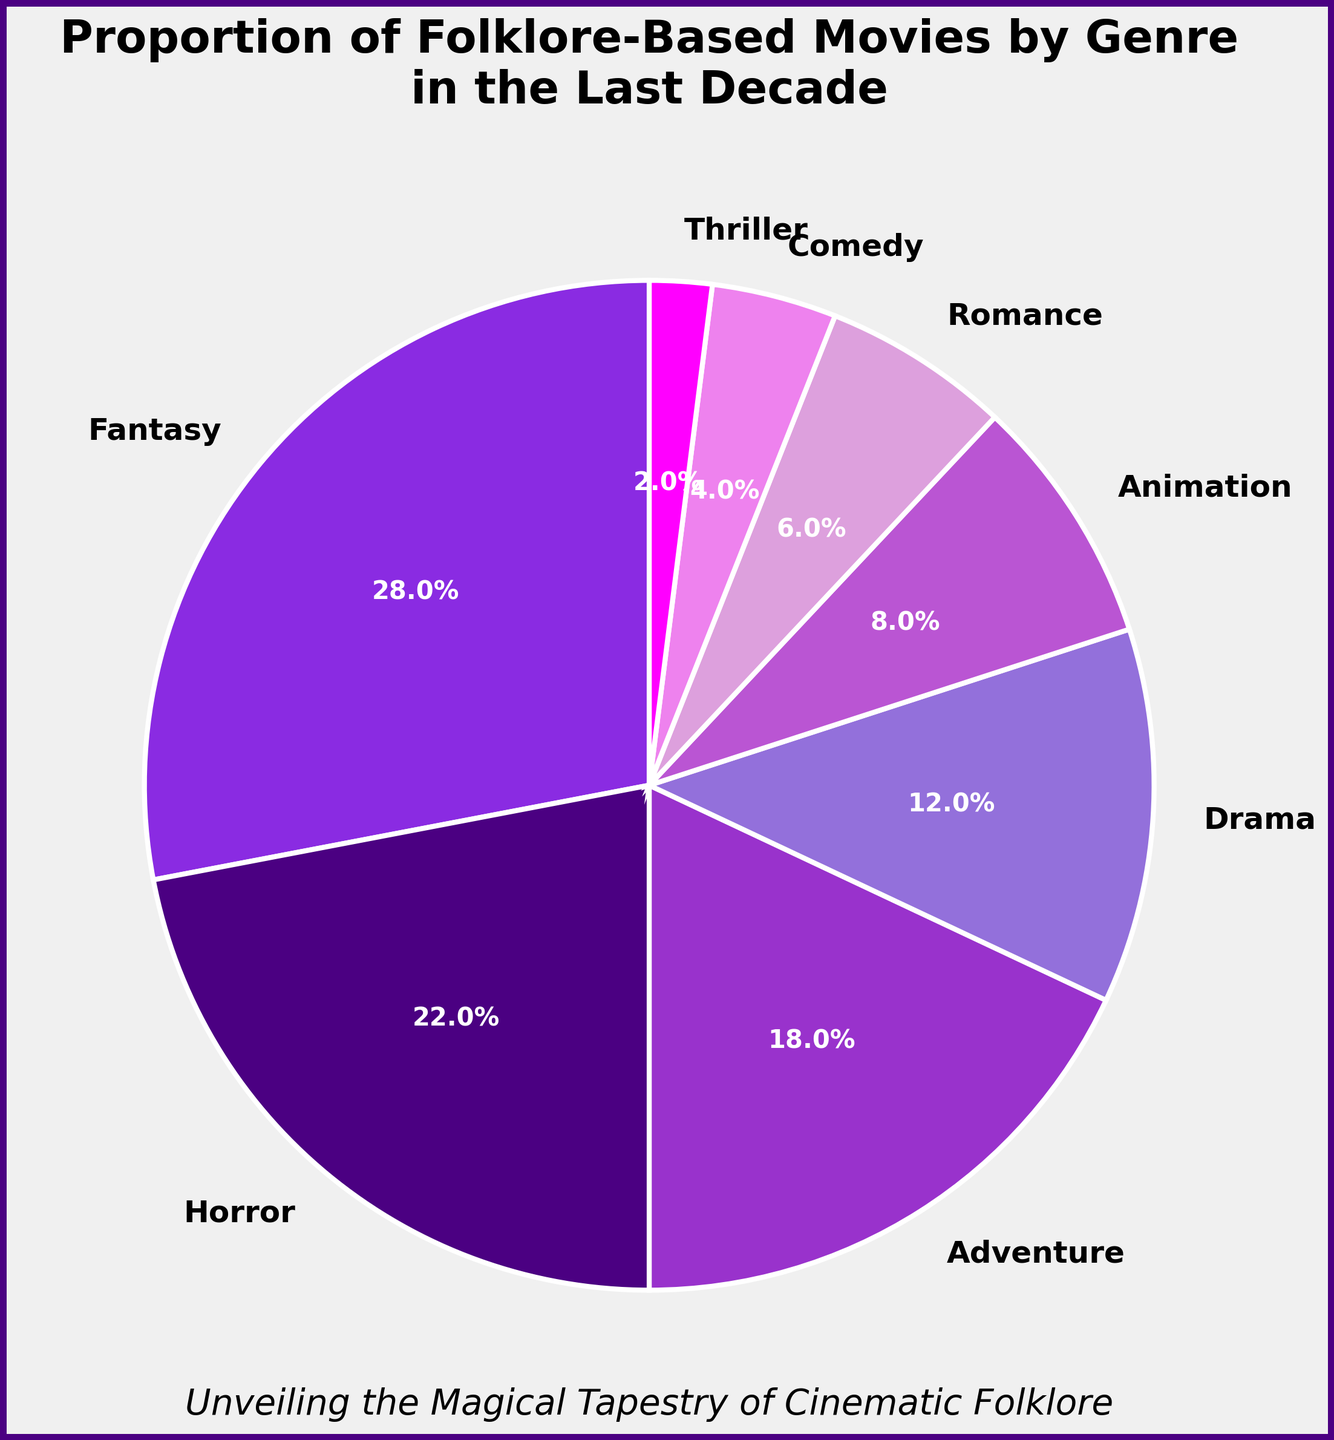What genre has the highest proportion of folklore-based movies? By observing the pie chart, the genre with the largest wedge is the one with the highest proportion. The genre labeled "Fantasy" has the largest wedge.
Answer: Fantasy Between Horror and Comedy, which genre has a higher percentage of folklore-based movies? Comparing the sizes of the wedges labeled "Horror" and "Comedy", "Horror" is significantly larger than "Comedy".
Answer: Horror What is the combined percentage of folklore-based movies in the Drama and Animation genres? The wedges for Drama and Animation can be individually identified and their percentages summed. Drama is 12% and Animation is 8%. The combined percentage is 12% + 8% = 20%.
Answer: 20% How much larger is the proportion of Adventure movies compared to Thriller movies? Identify the respective wedges for Adventure and Thriller. Adventure has 18% and Thriller has 2%. The difference is 18% - 2% = 16%.
Answer: 16% Which genre is the least represented in folklore-based movies? The wedge with the smallest size represents the least percentage. The "Thriller" genre has the smallest wedge.
Answer: Thriller What is the total percentage of folklore-based movies in genres with a proportion below 10%? Summing the percentages of genres with wedges below 10%: Animation (8%), Romance (6%), Comedy (4%), and Thriller (2%). The total is 8% + 6% + 4% + 2% = 20%.
Answer: 20% Are there more folklore-based Horror or Romance movies? Comparing the wedges for Horror and Romance, Horror has 22% while Romance has 6%. Hence, there are more Horror movies.
Answer: Horror Which color represents the genre with the second-highest percentage of folklore-based movies and what is that genre? By observing the pie chart, the second-largest wedge is for Horror, which is represented by dark purple.
Answer: Dark purple, Horror What is the average percentage of folklore-based movies in the Adventure, Drama, and Romance genres? Averaging the percentages for Adventure (18%), Drama (12%), and Romance (6%) involves summing these percentages (18% + 12% + 6% = 36%) and dividing by the number of genres (3). So, the average is 36% / 3 = 12%.
Answer: 12% Compare the combined percentage of Horror, Adventure, and Drama to Fantasy. Which is larger? Sum the percentages of Horror (22%), Adventure (18%), and Drama (12%), which gives 52%. Fantasy is 28%. 52% is larger than 28%.
Answer: Horror, Adventure, and Drama combined 